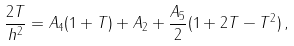<formula> <loc_0><loc_0><loc_500><loc_500>\frac { 2 T } { h ^ { 2 } } = A _ { 4 } ( 1 + T ) + A _ { 2 } + \frac { A _ { 5 } } { 2 } ( 1 + 2 T - T ^ { 2 } ) \, ,</formula> 